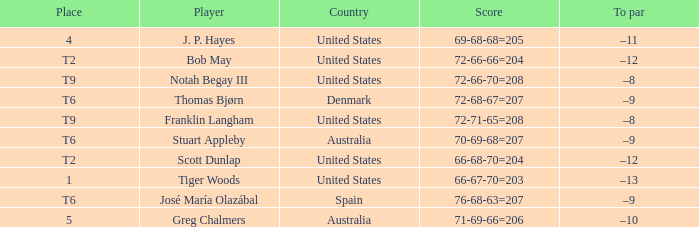What is the place of the player with a 66-68-70=204 score? T2. 